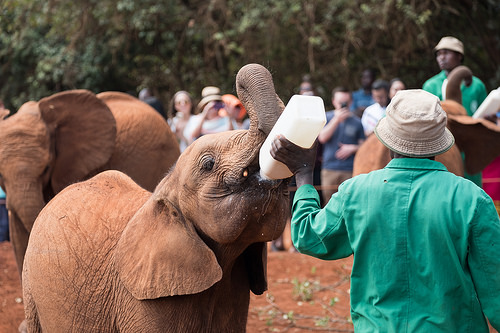<image>
Is there a milk on the elephant? No. The milk is not positioned on the elephant. They may be near each other, but the milk is not supported by or resting on top of the elephant. Is there a bottle behind the man? No. The bottle is not behind the man. From this viewpoint, the bottle appears to be positioned elsewhere in the scene. 